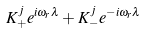Convert formula to latex. <formula><loc_0><loc_0><loc_500><loc_500>K _ { + } ^ { j } e ^ { i \omega _ { r } \lambda } + K _ { - } ^ { j } e ^ { - i \omega _ { r } \lambda }</formula> 